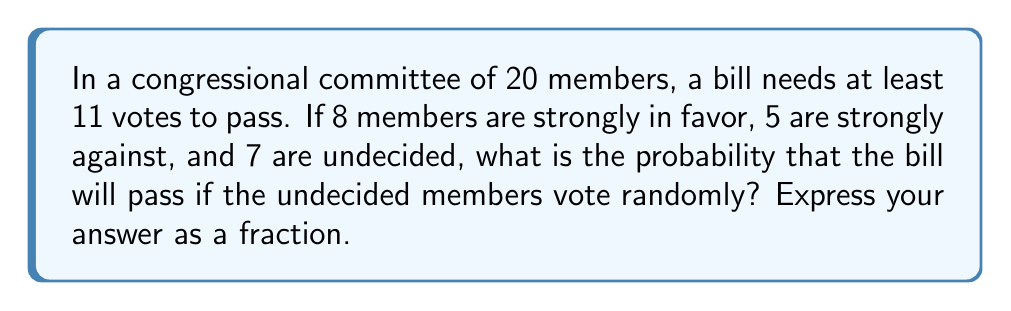Help me with this question. Let's approach this step-by-step using combinatorial methods:

1) We need at least 11 votes for the bill to pass. We already have 8 strong supporters, so we need at least 3 more votes from the 7 undecided members.

2) The number of favorable outcomes is the sum of cases where we get 3, 4, 5, 6, or 7 votes from the undecided members.

3) We can calculate this using the combination formula:

   $$\sum_{i=3}^7 \binom{7}{i}$$

4) Let's calculate each term:
   $$\binom{7}{3} = 35$$
   $$\binom{7}{4} = 35$$
   $$\binom{7}{5} = 21$$
   $$\binom{7}{6} = 7$$
   $$\binom{7}{7} = 1$$

5) Sum these up: 35 + 35 + 21 + 7 + 1 = 99

6) The total number of possible outcomes is $2^7 = 128$, as each of the 7 undecided members has 2 choices.

7) Therefore, the probability is:

   $$P(\text{bill passes}) = \frac{99}{128}$$
Answer: $\frac{99}{128}$ 